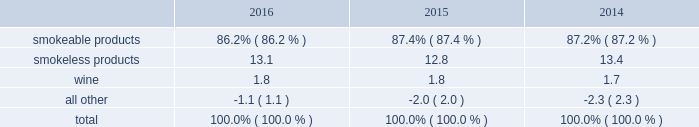The relative percentages of operating companies income ( loss ) attributable to each reportable segment and the all other category were as follows: .
For items affecting the comparability of the relative percentages of operating companies income ( loss ) attributable to each reportable segment , see note 16 .
Narrative description of business portions of the information called for by this item are included in operating results by business segment in item 7 .
Management 2019s discussion and analysis of financial condition and results of operations of this annual report on form 10-k ( 201citem 7 201d ) .
Tobacco space altria group , inc . 2019s tobacco operating companies include pm usa , usstc and other subsidiaries of ust , middleton , nu mark and nat sherman .
Altria group distribution company provides sales , distribution and consumer engagement services to altria group , inc . 2019s tobacco operating companies .
The products of altria group , inc . 2019s tobacco subsidiaries include smokeable tobacco products , consisting of cigarettes manufactured and sold by pm usa and nat sherman , machine- made large cigars and pipe tobacco manufactured and sold by middleton and premium cigars sold by nat sherman ; smokeless tobacco products manufactured and sold by usstc ; and innovative tobacco products , including e-vapor products manufactured and sold by nu mark .
Cigarettes : pm usa is the largest cigarette company in the united states , with total cigarette shipment volume in the united states of approximately 122.9 billion units in 2016 , a decrease of 2.5% ( 2.5 % ) from 2015 .
Marlboro , the principal cigarette brand of pm usa , has been the largest-selling cigarette brand in the united states for over 40 years .
Nat sherman sells substantially all of its super-premium cigarettes in the united states .
Cigars : middleton is engaged in the manufacture and sale of machine-made large cigars and pipe tobacco to customers , substantially all of which are located in the united states .
Middleton sources a portion of its cigars from an importer through a third-party contract manufacturing arrangement .
Total shipment volume for cigars was approximately 1.4 billion units in 2016 , an increase of 5.9% ( 5.9 % ) from 2015 .
Black & mild is the principal cigar brand of middleton .
Nat sherman sources its premium cigars from importers through third-party contract manufacturing arrangements and sells substantially all of its cigars in the united states .
Smokeless tobacco products : usstc is the leading producer and marketer of moist smokeless tobacco ( 201cmst 201d ) products .
The smokeless products segment includes the premium brands , copenhagen and skoal , and value brands , red seal and husky .
Substantially all of the smokeless tobacco products are manufactured and sold to customers in the united states .
Total smokeless products shipment volume was 853.5 million units in 2016 , an increase of 4.9% ( 4.9 % ) from 2015 .
Innovative tobacco products : nu mark participates in the e-vapor category and has developed and commercialized other innovative tobacco products .
In addition , nu mark sources the production of its e-vapor products through overseas contract manufacturing arrangements .
In 2013 , nu mark introduced markten e-vapor products .
In april 2014 , nu mark acquired the e-vapor business of green smoke , inc .
And its affiliates ( 201cgreen smoke 201d ) , which began selling e-vapor products in 2009 .
For a further discussion of the acquisition of green smoke , see note 3 .
Acquisition of green smoke to the consolidated financial statements in item 8 ( 201cnote 3 201d ) .
In december 2013 , altria group , inc . 2019s subsidiaries entered into a series of agreements with philip morris international inc .
( 201cpmi 201d ) pursuant to which altria group , inc . 2019s subsidiaries provide an exclusive license to pmi to sell nu mark 2019s e-vapor products outside the united states , and pmi 2019s subsidiaries provide an exclusive license to altria group , inc . 2019s subsidiaries to sell two of pmi 2019s heated tobacco product platforms in the united states .
Further , in july 2015 , altria group , inc .
Announced the expansion of its strategic framework with pmi to include a joint research , development and technology-sharing agreement .
Under this agreement , altria group , inc . 2019s subsidiaries and pmi will collaborate to develop e-vapor products for commercialization in the united states by altria group , inc . 2019s subsidiaries and in markets outside the united states by pmi .
This agreement also provides for exclusive technology cross licenses , technical information sharing and cooperation on scientific assessment , regulatory engagement and approval related to e-vapor products .
In the fourth quarter of 2016 , pmi submitted a modified risk tobacco product ( 201cmrtp 201d ) application for an electronically heated tobacco product with the united states food and drug administration 2019s ( 201cfda 201d ) center for tobacco products and announced that it plans to file its corresponding pre-market tobacco product application during the first quarter of 2017 .
The fda must determine whether to accept the applications for substantive review .
Upon regulatory authorization by the fda , altria group , inc . 2019s subsidiaries will have an exclusive license to sell this heated tobacco product in the united states .
Distribution , competition and raw materials : altria group , inc . 2019s tobacco subsidiaries sell their tobacco products principally to wholesalers ( including distributors ) , large retail organizations , including chain stores , and the armed services .
The market for tobacco products is highly competitive , characterized by brand recognition and loyalty , with product quality , taste , price , product innovation , marketing , packaging and distribution constituting the significant methods of competition .
Promotional activities include , in certain instances and where .
What would 2017 cigarette shipment volume in the united states be in billions if the same revenue change in 2016 occured? 
Computations: (122.9 - 2.5%)
Answer: 122.875. 